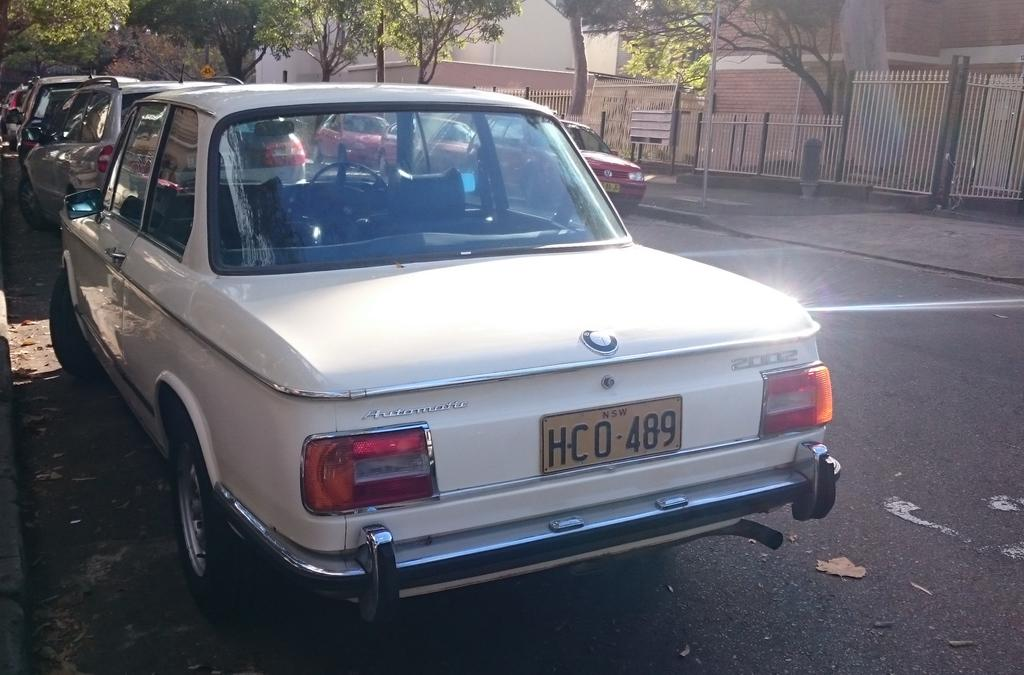What type of vehicles can be seen on the road in the image? There are cars on the road in the image. What natural elements are present in the image? There are trees in the image. What man-made structures can be seen in the image? There are buildings in the image. What type of barrier is visible in the image? There is a fence in the image. Can you see any stitches on the cars in the image? There are no stitches present on the cars in the image. What type of wax is used to create the buildings in the image? The buildings in the image are not made of wax; they are likely made of concrete or other materials. 